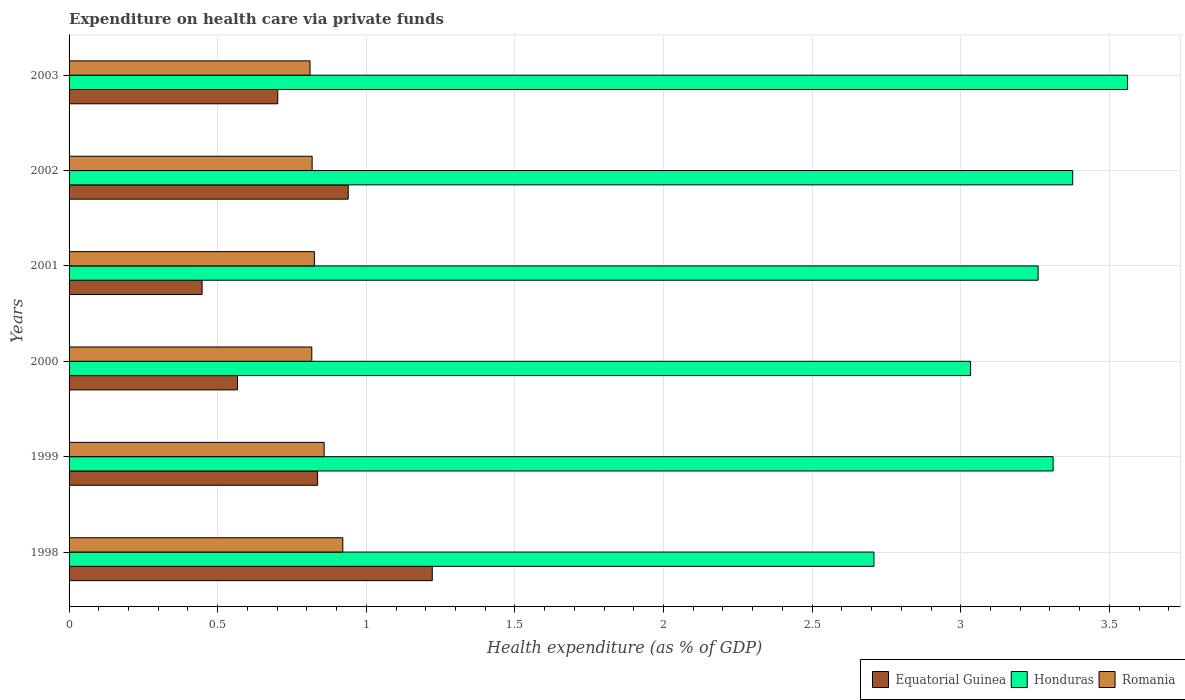How many different coloured bars are there?
Your response must be concise. 3. Are the number of bars per tick equal to the number of legend labels?
Your answer should be very brief. Yes. Are the number of bars on each tick of the Y-axis equal?
Your answer should be very brief. Yes. What is the label of the 2nd group of bars from the top?
Provide a succinct answer. 2002. In how many cases, is the number of bars for a given year not equal to the number of legend labels?
Your answer should be very brief. 0. What is the expenditure made on health care in Equatorial Guinea in 2000?
Provide a succinct answer. 0.57. Across all years, what is the maximum expenditure made on health care in Honduras?
Your response must be concise. 3.56. Across all years, what is the minimum expenditure made on health care in Romania?
Ensure brevity in your answer.  0.81. In which year was the expenditure made on health care in Equatorial Guinea maximum?
Keep it short and to the point. 1998. What is the total expenditure made on health care in Equatorial Guinea in the graph?
Offer a very short reply. 4.71. What is the difference between the expenditure made on health care in Honduras in 1998 and that in 2000?
Your response must be concise. -0.33. What is the difference between the expenditure made on health care in Romania in 1998 and the expenditure made on health care in Equatorial Guinea in 2001?
Give a very brief answer. 0.47. What is the average expenditure made on health care in Honduras per year?
Your response must be concise. 3.21. In the year 2002, what is the difference between the expenditure made on health care in Equatorial Guinea and expenditure made on health care in Romania?
Provide a succinct answer. 0.12. In how many years, is the expenditure made on health care in Equatorial Guinea greater than 2.4 %?
Your answer should be compact. 0. What is the ratio of the expenditure made on health care in Honduras in 1998 to that in 2000?
Provide a succinct answer. 0.89. Is the expenditure made on health care in Equatorial Guinea in 2000 less than that in 2003?
Your answer should be very brief. Yes. What is the difference between the highest and the second highest expenditure made on health care in Romania?
Your answer should be very brief. 0.06. What is the difference between the highest and the lowest expenditure made on health care in Equatorial Guinea?
Your answer should be very brief. 0.77. In how many years, is the expenditure made on health care in Romania greater than the average expenditure made on health care in Romania taken over all years?
Your answer should be very brief. 2. Is the sum of the expenditure made on health care in Equatorial Guinea in 1999 and 2001 greater than the maximum expenditure made on health care in Honduras across all years?
Give a very brief answer. No. What does the 2nd bar from the top in 2000 represents?
Your answer should be compact. Honduras. What does the 2nd bar from the bottom in 2001 represents?
Your response must be concise. Honduras. Is it the case that in every year, the sum of the expenditure made on health care in Equatorial Guinea and expenditure made on health care in Honduras is greater than the expenditure made on health care in Romania?
Keep it short and to the point. Yes. How many bars are there?
Give a very brief answer. 18. Are all the bars in the graph horizontal?
Keep it short and to the point. Yes. Are the values on the major ticks of X-axis written in scientific E-notation?
Your answer should be compact. No. Does the graph contain grids?
Your response must be concise. Yes. How many legend labels are there?
Provide a short and direct response. 3. How are the legend labels stacked?
Offer a terse response. Horizontal. What is the title of the graph?
Offer a terse response. Expenditure on health care via private funds. What is the label or title of the X-axis?
Offer a terse response. Health expenditure (as % of GDP). What is the label or title of the Y-axis?
Ensure brevity in your answer.  Years. What is the Health expenditure (as % of GDP) in Equatorial Guinea in 1998?
Your answer should be very brief. 1.22. What is the Health expenditure (as % of GDP) in Honduras in 1998?
Provide a succinct answer. 2.71. What is the Health expenditure (as % of GDP) of Romania in 1998?
Provide a succinct answer. 0.92. What is the Health expenditure (as % of GDP) in Equatorial Guinea in 1999?
Provide a succinct answer. 0.84. What is the Health expenditure (as % of GDP) of Honduras in 1999?
Ensure brevity in your answer.  3.31. What is the Health expenditure (as % of GDP) in Romania in 1999?
Offer a terse response. 0.86. What is the Health expenditure (as % of GDP) in Equatorial Guinea in 2000?
Keep it short and to the point. 0.57. What is the Health expenditure (as % of GDP) in Honduras in 2000?
Your answer should be compact. 3.03. What is the Health expenditure (as % of GDP) in Romania in 2000?
Ensure brevity in your answer.  0.82. What is the Health expenditure (as % of GDP) of Equatorial Guinea in 2001?
Your answer should be very brief. 0.45. What is the Health expenditure (as % of GDP) in Honduras in 2001?
Ensure brevity in your answer.  3.26. What is the Health expenditure (as % of GDP) in Romania in 2001?
Give a very brief answer. 0.83. What is the Health expenditure (as % of GDP) of Equatorial Guinea in 2002?
Your response must be concise. 0.94. What is the Health expenditure (as % of GDP) of Honduras in 2002?
Make the answer very short. 3.38. What is the Health expenditure (as % of GDP) in Romania in 2002?
Offer a very short reply. 0.82. What is the Health expenditure (as % of GDP) of Equatorial Guinea in 2003?
Provide a short and direct response. 0.7. What is the Health expenditure (as % of GDP) of Honduras in 2003?
Give a very brief answer. 3.56. What is the Health expenditure (as % of GDP) in Romania in 2003?
Make the answer very short. 0.81. Across all years, what is the maximum Health expenditure (as % of GDP) in Equatorial Guinea?
Provide a succinct answer. 1.22. Across all years, what is the maximum Health expenditure (as % of GDP) in Honduras?
Give a very brief answer. 3.56. Across all years, what is the maximum Health expenditure (as % of GDP) in Romania?
Provide a succinct answer. 0.92. Across all years, what is the minimum Health expenditure (as % of GDP) of Equatorial Guinea?
Keep it short and to the point. 0.45. Across all years, what is the minimum Health expenditure (as % of GDP) of Honduras?
Provide a succinct answer. 2.71. Across all years, what is the minimum Health expenditure (as % of GDP) in Romania?
Ensure brevity in your answer.  0.81. What is the total Health expenditure (as % of GDP) in Equatorial Guinea in the graph?
Your answer should be very brief. 4.71. What is the total Health expenditure (as % of GDP) in Honduras in the graph?
Your response must be concise. 19.25. What is the total Health expenditure (as % of GDP) in Romania in the graph?
Provide a short and direct response. 5.05. What is the difference between the Health expenditure (as % of GDP) in Equatorial Guinea in 1998 and that in 1999?
Provide a short and direct response. 0.39. What is the difference between the Health expenditure (as % of GDP) of Honduras in 1998 and that in 1999?
Your answer should be very brief. -0.6. What is the difference between the Health expenditure (as % of GDP) of Romania in 1998 and that in 1999?
Provide a succinct answer. 0.06. What is the difference between the Health expenditure (as % of GDP) in Equatorial Guinea in 1998 and that in 2000?
Your answer should be compact. 0.66. What is the difference between the Health expenditure (as % of GDP) of Honduras in 1998 and that in 2000?
Your answer should be very brief. -0.33. What is the difference between the Health expenditure (as % of GDP) in Romania in 1998 and that in 2000?
Your answer should be very brief. 0.1. What is the difference between the Health expenditure (as % of GDP) in Equatorial Guinea in 1998 and that in 2001?
Your answer should be compact. 0.77. What is the difference between the Health expenditure (as % of GDP) of Honduras in 1998 and that in 2001?
Provide a succinct answer. -0.55. What is the difference between the Health expenditure (as % of GDP) of Romania in 1998 and that in 2001?
Your answer should be very brief. 0.1. What is the difference between the Health expenditure (as % of GDP) in Equatorial Guinea in 1998 and that in 2002?
Offer a terse response. 0.28. What is the difference between the Health expenditure (as % of GDP) in Honduras in 1998 and that in 2002?
Provide a short and direct response. -0.67. What is the difference between the Health expenditure (as % of GDP) of Romania in 1998 and that in 2002?
Make the answer very short. 0.1. What is the difference between the Health expenditure (as % of GDP) in Equatorial Guinea in 1998 and that in 2003?
Your answer should be very brief. 0.52. What is the difference between the Health expenditure (as % of GDP) in Honduras in 1998 and that in 2003?
Offer a very short reply. -0.85. What is the difference between the Health expenditure (as % of GDP) of Romania in 1998 and that in 2003?
Your answer should be compact. 0.11. What is the difference between the Health expenditure (as % of GDP) in Equatorial Guinea in 1999 and that in 2000?
Your answer should be very brief. 0.27. What is the difference between the Health expenditure (as % of GDP) in Honduras in 1999 and that in 2000?
Your response must be concise. 0.28. What is the difference between the Health expenditure (as % of GDP) of Romania in 1999 and that in 2000?
Offer a very short reply. 0.04. What is the difference between the Health expenditure (as % of GDP) of Equatorial Guinea in 1999 and that in 2001?
Offer a very short reply. 0.39. What is the difference between the Health expenditure (as % of GDP) of Honduras in 1999 and that in 2001?
Ensure brevity in your answer.  0.05. What is the difference between the Health expenditure (as % of GDP) of Romania in 1999 and that in 2001?
Give a very brief answer. 0.03. What is the difference between the Health expenditure (as % of GDP) of Equatorial Guinea in 1999 and that in 2002?
Give a very brief answer. -0.1. What is the difference between the Health expenditure (as % of GDP) in Honduras in 1999 and that in 2002?
Offer a very short reply. -0.07. What is the difference between the Health expenditure (as % of GDP) of Romania in 1999 and that in 2002?
Provide a succinct answer. 0.04. What is the difference between the Health expenditure (as % of GDP) in Equatorial Guinea in 1999 and that in 2003?
Your answer should be very brief. 0.13. What is the difference between the Health expenditure (as % of GDP) of Honduras in 1999 and that in 2003?
Ensure brevity in your answer.  -0.25. What is the difference between the Health expenditure (as % of GDP) in Romania in 1999 and that in 2003?
Your answer should be compact. 0.05. What is the difference between the Health expenditure (as % of GDP) in Equatorial Guinea in 2000 and that in 2001?
Your answer should be compact. 0.12. What is the difference between the Health expenditure (as % of GDP) of Honduras in 2000 and that in 2001?
Ensure brevity in your answer.  -0.23. What is the difference between the Health expenditure (as % of GDP) of Romania in 2000 and that in 2001?
Your answer should be compact. -0.01. What is the difference between the Health expenditure (as % of GDP) of Equatorial Guinea in 2000 and that in 2002?
Give a very brief answer. -0.37. What is the difference between the Health expenditure (as % of GDP) of Honduras in 2000 and that in 2002?
Your answer should be very brief. -0.34. What is the difference between the Health expenditure (as % of GDP) of Romania in 2000 and that in 2002?
Ensure brevity in your answer.  -0. What is the difference between the Health expenditure (as % of GDP) in Equatorial Guinea in 2000 and that in 2003?
Provide a short and direct response. -0.14. What is the difference between the Health expenditure (as % of GDP) in Honduras in 2000 and that in 2003?
Offer a very short reply. -0.53. What is the difference between the Health expenditure (as % of GDP) of Romania in 2000 and that in 2003?
Offer a very short reply. 0.01. What is the difference between the Health expenditure (as % of GDP) of Equatorial Guinea in 2001 and that in 2002?
Give a very brief answer. -0.49. What is the difference between the Health expenditure (as % of GDP) in Honduras in 2001 and that in 2002?
Ensure brevity in your answer.  -0.12. What is the difference between the Health expenditure (as % of GDP) in Romania in 2001 and that in 2002?
Ensure brevity in your answer.  0.01. What is the difference between the Health expenditure (as % of GDP) in Equatorial Guinea in 2001 and that in 2003?
Give a very brief answer. -0.25. What is the difference between the Health expenditure (as % of GDP) in Honduras in 2001 and that in 2003?
Offer a very short reply. -0.3. What is the difference between the Health expenditure (as % of GDP) in Romania in 2001 and that in 2003?
Your response must be concise. 0.01. What is the difference between the Health expenditure (as % of GDP) in Equatorial Guinea in 2002 and that in 2003?
Give a very brief answer. 0.24. What is the difference between the Health expenditure (as % of GDP) in Honduras in 2002 and that in 2003?
Offer a very short reply. -0.18. What is the difference between the Health expenditure (as % of GDP) in Romania in 2002 and that in 2003?
Your response must be concise. 0.01. What is the difference between the Health expenditure (as % of GDP) of Equatorial Guinea in 1998 and the Health expenditure (as % of GDP) of Honduras in 1999?
Your answer should be very brief. -2.09. What is the difference between the Health expenditure (as % of GDP) in Equatorial Guinea in 1998 and the Health expenditure (as % of GDP) in Romania in 1999?
Provide a succinct answer. 0.36. What is the difference between the Health expenditure (as % of GDP) in Honduras in 1998 and the Health expenditure (as % of GDP) in Romania in 1999?
Your response must be concise. 1.85. What is the difference between the Health expenditure (as % of GDP) in Equatorial Guinea in 1998 and the Health expenditure (as % of GDP) in Honduras in 2000?
Your answer should be compact. -1.81. What is the difference between the Health expenditure (as % of GDP) of Equatorial Guinea in 1998 and the Health expenditure (as % of GDP) of Romania in 2000?
Your answer should be compact. 0.41. What is the difference between the Health expenditure (as % of GDP) of Honduras in 1998 and the Health expenditure (as % of GDP) of Romania in 2000?
Offer a very short reply. 1.89. What is the difference between the Health expenditure (as % of GDP) in Equatorial Guinea in 1998 and the Health expenditure (as % of GDP) in Honduras in 2001?
Your response must be concise. -2.04. What is the difference between the Health expenditure (as % of GDP) of Equatorial Guinea in 1998 and the Health expenditure (as % of GDP) of Romania in 2001?
Offer a very short reply. 0.4. What is the difference between the Health expenditure (as % of GDP) in Honduras in 1998 and the Health expenditure (as % of GDP) in Romania in 2001?
Keep it short and to the point. 1.88. What is the difference between the Health expenditure (as % of GDP) of Equatorial Guinea in 1998 and the Health expenditure (as % of GDP) of Honduras in 2002?
Offer a terse response. -2.15. What is the difference between the Health expenditure (as % of GDP) in Equatorial Guinea in 1998 and the Health expenditure (as % of GDP) in Romania in 2002?
Give a very brief answer. 0.4. What is the difference between the Health expenditure (as % of GDP) of Honduras in 1998 and the Health expenditure (as % of GDP) of Romania in 2002?
Ensure brevity in your answer.  1.89. What is the difference between the Health expenditure (as % of GDP) in Equatorial Guinea in 1998 and the Health expenditure (as % of GDP) in Honduras in 2003?
Your answer should be very brief. -2.34. What is the difference between the Health expenditure (as % of GDP) in Equatorial Guinea in 1998 and the Health expenditure (as % of GDP) in Romania in 2003?
Provide a short and direct response. 0.41. What is the difference between the Health expenditure (as % of GDP) of Honduras in 1998 and the Health expenditure (as % of GDP) of Romania in 2003?
Offer a very short reply. 1.9. What is the difference between the Health expenditure (as % of GDP) in Equatorial Guinea in 1999 and the Health expenditure (as % of GDP) in Honduras in 2000?
Offer a very short reply. -2.2. What is the difference between the Health expenditure (as % of GDP) in Equatorial Guinea in 1999 and the Health expenditure (as % of GDP) in Romania in 2000?
Ensure brevity in your answer.  0.02. What is the difference between the Health expenditure (as % of GDP) in Honduras in 1999 and the Health expenditure (as % of GDP) in Romania in 2000?
Ensure brevity in your answer.  2.49. What is the difference between the Health expenditure (as % of GDP) of Equatorial Guinea in 1999 and the Health expenditure (as % of GDP) of Honduras in 2001?
Provide a succinct answer. -2.42. What is the difference between the Health expenditure (as % of GDP) of Equatorial Guinea in 1999 and the Health expenditure (as % of GDP) of Romania in 2001?
Your response must be concise. 0.01. What is the difference between the Health expenditure (as % of GDP) of Honduras in 1999 and the Health expenditure (as % of GDP) of Romania in 2001?
Keep it short and to the point. 2.49. What is the difference between the Health expenditure (as % of GDP) in Equatorial Guinea in 1999 and the Health expenditure (as % of GDP) in Honduras in 2002?
Your answer should be compact. -2.54. What is the difference between the Health expenditure (as % of GDP) of Equatorial Guinea in 1999 and the Health expenditure (as % of GDP) of Romania in 2002?
Offer a very short reply. 0.02. What is the difference between the Health expenditure (as % of GDP) of Honduras in 1999 and the Health expenditure (as % of GDP) of Romania in 2002?
Keep it short and to the point. 2.49. What is the difference between the Health expenditure (as % of GDP) of Equatorial Guinea in 1999 and the Health expenditure (as % of GDP) of Honduras in 2003?
Offer a terse response. -2.73. What is the difference between the Health expenditure (as % of GDP) of Equatorial Guinea in 1999 and the Health expenditure (as % of GDP) of Romania in 2003?
Ensure brevity in your answer.  0.03. What is the difference between the Health expenditure (as % of GDP) in Honduras in 1999 and the Health expenditure (as % of GDP) in Romania in 2003?
Make the answer very short. 2.5. What is the difference between the Health expenditure (as % of GDP) in Equatorial Guinea in 2000 and the Health expenditure (as % of GDP) in Honduras in 2001?
Provide a short and direct response. -2.69. What is the difference between the Health expenditure (as % of GDP) in Equatorial Guinea in 2000 and the Health expenditure (as % of GDP) in Romania in 2001?
Make the answer very short. -0.26. What is the difference between the Health expenditure (as % of GDP) in Honduras in 2000 and the Health expenditure (as % of GDP) in Romania in 2001?
Your answer should be compact. 2.21. What is the difference between the Health expenditure (as % of GDP) in Equatorial Guinea in 2000 and the Health expenditure (as % of GDP) in Honduras in 2002?
Make the answer very short. -2.81. What is the difference between the Health expenditure (as % of GDP) in Equatorial Guinea in 2000 and the Health expenditure (as % of GDP) in Romania in 2002?
Keep it short and to the point. -0.25. What is the difference between the Health expenditure (as % of GDP) in Honduras in 2000 and the Health expenditure (as % of GDP) in Romania in 2002?
Make the answer very short. 2.22. What is the difference between the Health expenditure (as % of GDP) in Equatorial Guinea in 2000 and the Health expenditure (as % of GDP) in Honduras in 2003?
Provide a succinct answer. -2.99. What is the difference between the Health expenditure (as % of GDP) in Equatorial Guinea in 2000 and the Health expenditure (as % of GDP) in Romania in 2003?
Ensure brevity in your answer.  -0.24. What is the difference between the Health expenditure (as % of GDP) of Honduras in 2000 and the Health expenditure (as % of GDP) of Romania in 2003?
Provide a short and direct response. 2.22. What is the difference between the Health expenditure (as % of GDP) in Equatorial Guinea in 2001 and the Health expenditure (as % of GDP) in Honduras in 2002?
Ensure brevity in your answer.  -2.93. What is the difference between the Health expenditure (as % of GDP) in Equatorial Guinea in 2001 and the Health expenditure (as % of GDP) in Romania in 2002?
Your answer should be compact. -0.37. What is the difference between the Health expenditure (as % of GDP) in Honduras in 2001 and the Health expenditure (as % of GDP) in Romania in 2002?
Offer a terse response. 2.44. What is the difference between the Health expenditure (as % of GDP) of Equatorial Guinea in 2001 and the Health expenditure (as % of GDP) of Honduras in 2003?
Keep it short and to the point. -3.11. What is the difference between the Health expenditure (as % of GDP) in Equatorial Guinea in 2001 and the Health expenditure (as % of GDP) in Romania in 2003?
Offer a terse response. -0.36. What is the difference between the Health expenditure (as % of GDP) in Honduras in 2001 and the Health expenditure (as % of GDP) in Romania in 2003?
Your response must be concise. 2.45. What is the difference between the Health expenditure (as % of GDP) of Equatorial Guinea in 2002 and the Health expenditure (as % of GDP) of Honduras in 2003?
Your answer should be very brief. -2.62. What is the difference between the Health expenditure (as % of GDP) of Equatorial Guinea in 2002 and the Health expenditure (as % of GDP) of Romania in 2003?
Provide a succinct answer. 0.13. What is the difference between the Health expenditure (as % of GDP) in Honduras in 2002 and the Health expenditure (as % of GDP) in Romania in 2003?
Your answer should be compact. 2.57. What is the average Health expenditure (as % of GDP) of Equatorial Guinea per year?
Your answer should be compact. 0.79. What is the average Health expenditure (as % of GDP) of Honduras per year?
Ensure brevity in your answer.  3.21. What is the average Health expenditure (as % of GDP) in Romania per year?
Your response must be concise. 0.84. In the year 1998, what is the difference between the Health expenditure (as % of GDP) of Equatorial Guinea and Health expenditure (as % of GDP) of Honduras?
Keep it short and to the point. -1.49. In the year 1998, what is the difference between the Health expenditure (as % of GDP) in Equatorial Guinea and Health expenditure (as % of GDP) in Romania?
Your response must be concise. 0.3. In the year 1998, what is the difference between the Health expenditure (as % of GDP) of Honduras and Health expenditure (as % of GDP) of Romania?
Give a very brief answer. 1.79. In the year 1999, what is the difference between the Health expenditure (as % of GDP) in Equatorial Guinea and Health expenditure (as % of GDP) in Honduras?
Give a very brief answer. -2.47. In the year 1999, what is the difference between the Health expenditure (as % of GDP) of Equatorial Guinea and Health expenditure (as % of GDP) of Romania?
Your response must be concise. -0.02. In the year 1999, what is the difference between the Health expenditure (as % of GDP) of Honduras and Health expenditure (as % of GDP) of Romania?
Provide a short and direct response. 2.45. In the year 2000, what is the difference between the Health expenditure (as % of GDP) in Equatorial Guinea and Health expenditure (as % of GDP) in Honduras?
Provide a short and direct response. -2.47. In the year 2000, what is the difference between the Health expenditure (as % of GDP) of Equatorial Guinea and Health expenditure (as % of GDP) of Romania?
Ensure brevity in your answer.  -0.25. In the year 2000, what is the difference between the Health expenditure (as % of GDP) in Honduras and Health expenditure (as % of GDP) in Romania?
Your answer should be compact. 2.22. In the year 2001, what is the difference between the Health expenditure (as % of GDP) in Equatorial Guinea and Health expenditure (as % of GDP) in Honduras?
Offer a very short reply. -2.81. In the year 2001, what is the difference between the Health expenditure (as % of GDP) in Equatorial Guinea and Health expenditure (as % of GDP) in Romania?
Offer a terse response. -0.38. In the year 2001, what is the difference between the Health expenditure (as % of GDP) of Honduras and Health expenditure (as % of GDP) of Romania?
Give a very brief answer. 2.44. In the year 2002, what is the difference between the Health expenditure (as % of GDP) of Equatorial Guinea and Health expenditure (as % of GDP) of Honduras?
Ensure brevity in your answer.  -2.44. In the year 2002, what is the difference between the Health expenditure (as % of GDP) in Equatorial Guinea and Health expenditure (as % of GDP) in Romania?
Give a very brief answer. 0.12. In the year 2002, what is the difference between the Health expenditure (as % of GDP) of Honduras and Health expenditure (as % of GDP) of Romania?
Your answer should be compact. 2.56. In the year 2003, what is the difference between the Health expenditure (as % of GDP) of Equatorial Guinea and Health expenditure (as % of GDP) of Honduras?
Your answer should be compact. -2.86. In the year 2003, what is the difference between the Health expenditure (as % of GDP) of Equatorial Guinea and Health expenditure (as % of GDP) of Romania?
Ensure brevity in your answer.  -0.11. In the year 2003, what is the difference between the Health expenditure (as % of GDP) in Honduras and Health expenditure (as % of GDP) in Romania?
Your answer should be compact. 2.75. What is the ratio of the Health expenditure (as % of GDP) in Equatorial Guinea in 1998 to that in 1999?
Provide a short and direct response. 1.46. What is the ratio of the Health expenditure (as % of GDP) in Honduras in 1998 to that in 1999?
Your answer should be very brief. 0.82. What is the ratio of the Health expenditure (as % of GDP) of Romania in 1998 to that in 1999?
Provide a short and direct response. 1.07. What is the ratio of the Health expenditure (as % of GDP) of Equatorial Guinea in 1998 to that in 2000?
Your answer should be compact. 2.16. What is the ratio of the Health expenditure (as % of GDP) in Honduras in 1998 to that in 2000?
Give a very brief answer. 0.89. What is the ratio of the Health expenditure (as % of GDP) in Romania in 1998 to that in 2000?
Make the answer very short. 1.13. What is the ratio of the Health expenditure (as % of GDP) of Equatorial Guinea in 1998 to that in 2001?
Offer a very short reply. 2.73. What is the ratio of the Health expenditure (as % of GDP) in Honduras in 1998 to that in 2001?
Keep it short and to the point. 0.83. What is the ratio of the Health expenditure (as % of GDP) of Romania in 1998 to that in 2001?
Offer a terse response. 1.12. What is the ratio of the Health expenditure (as % of GDP) of Equatorial Guinea in 1998 to that in 2002?
Provide a short and direct response. 1.3. What is the ratio of the Health expenditure (as % of GDP) in Honduras in 1998 to that in 2002?
Provide a short and direct response. 0.8. What is the ratio of the Health expenditure (as % of GDP) of Romania in 1998 to that in 2002?
Provide a short and direct response. 1.13. What is the ratio of the Health expenditure (as % of GDP) of Equatorial Guinea in 1998 to that in 2003?
Make the answer very short. 1.74. What is the ratio of the Health expenditure (as % of GDP) of Honduras in 1998 to that in 2003?
Provide a succinct answer. 0.76. What is the ratio of the Health expenditure (as % of GDP) in Romania in 1998 to that in 2003?
Provide a short and direct response. 1.14. What is the ratio of the Health expenditure (as % of GDP) in Equatorial Guinea in 1999 to that in 2000?
Provide a succinct answer. 1.48. What is the ratio of the Health expenditure (as % of GDP) of Honduras in 1999 to that in 2000?
Your answer should be very brief. 1.09. What is the ratio of the Health expenditure (as % of GDP) in Romania in 1999 to that in 2000?
Offer a very short reply. 1.05. What is the ratio of the Health expenditure (as % of GDP) of Equatorial Guinea in 1999 to that in 2001?
Your answer should be compact. 1.87. What is the ratio of the Health expenditure (as % of GDP) in Honduras in 1999 to that in 2001?
Give a very brief answer. 1.02. What is the ratio of the Health expenditure (as % of GDP) of Romania in 1999 to that in 2001?
Your response must be concise. 1.04. What is the ratio of the Health expenditure (as % of GDP) in Equatorial Guinea in 1999 to that in 2002?
Your response must be concise. 0.89. What is the ratio of the Health expenditure (as % of GDP) in Honduras in 1999 to that in 2002?
Give a very brief answer. 0.98. What is the ratio of the Health expenditure (as % of GDP) of Romania in 1999 to that in 2002?
Your answer should be very brief. 1.05. What is the ratio of the Health expenditure (as % of GDP) in Equatorial Guinea in 1999 to that in 2003?
Your answer should be very brief. 1.19. What is the ratio of the Health expenditure (as % of GDP) of Honduras in 1999 to that in 2003?
Your answer should be very brief. 0.93. What is the ratio of the Health expenditure (as % of GDP) of Romania in 1999 to that in 2003?
Offer a very short reply. 1.06. What is the ratio of the Health expenditure (as % of GDP) in Equatorial Guinea in 2000 to that in 2001?
Offer a terse response. 1.27. What is the ratio of the Health expenditure (as % of GDP) of Honduras in 2000 to that in 2001?
Your answer should be compact. 0.93. What is the ratio of the Health expenditure (as % of GDP) in Romania in 2000 to that in 2001?
Your answer should be very brief. 0.99. What is the ratio of the Health expenditure (as % of GDP) of Equatorial Guinea in 2000 to that in 2002?
Your response must be concise. 0.6. What is the ratio of the Health expenditure (as % of GDP) in Honduras in 2000 to that in 2002?
Provide a succinct answer. 0.9. What is the ratio of the Health expenditure (as % of GDP) in Equatorial Guinea in 2000 to that in 2003?
Make the answer very short. 0.81. What is the ratio of the Health expenditure (as % of GDP) in Honduras in 2000 to that in 2003?
Your answer should be very brief. 0.85. What is the ratio of the Health expenditure (as % of GDP) in Romania in 2000 to that in 2003?
Give a very brief answer. 1.01. What is the ratio of the Health expenditure (as % of GDP) of Equatorial Guinea in 2001 to that in 2002?
Your answer should be compact. 0.48. What is the ratio of the Health expenditure (as % of GDP) of Honduras in 2001 to that in 2002?
Keep it short and to the point. 0.97. What is the ratio of the Health expenditure (as % of GDP) of Romania in 2001 to that in 2002?
Your response must be concise. 1.01. What is the ratio of the Health expenditure (as % of GDP) of Equatorial Guinea in 2001 to that in 2003?
Give a very brief answer. 0.64. What is the ratio of the Health expenditure (as % of GDP) of Honduras in 2001 to that in 2003?
Offer a very short reply. 0.92. What is the ratio of the Health expenditure (as % of GDP) in Romania in 2001 to that in 2003?
Your answer should be very brief. 1.02. What is the ratio of the Health expenditure (as % of GDP) in Equatorial Guinea in 2002 to that in 2003?
Keep it short and to the point. 1.34. What is the ratio of the Health expenditure (as % of GDP) in Honduras in 2002 to that in 2003?
Your answer should be very brief. 0.95. What is the ratio of the Health expenditure (as % of GDP) of Romania in 2002 to that in 2003?
Provide a short and direct response. 1.01. What is the difference between the highest and the second highest Health expenditure (as % of GDP) in Equatorial Guinea?
Your response must be concise. 0.28. What is the difference between the highest and the second highest Health expenditure (as % of GDP) of Honduras?
Keep it short and to the point. 0.18. What is the difference between the highest and the second highest Health expenditure (as % of GDP) in Romania?
Your response must be concise. 0.06. What is the difference between the highest and the lowest Health expenditure (as % of GDP) in Equatorial Guinea?
Provide a succinct answer. 0.77. What is the difference between the highest and the lowest Health expenditure (as % of GDP) of Honduras?
Keep it short and to the point. 0.85. What is the difference between the highest and the lowest Health expenditure (as % of GDP) of Romania?
Provide a succinct answer. 0.11. 